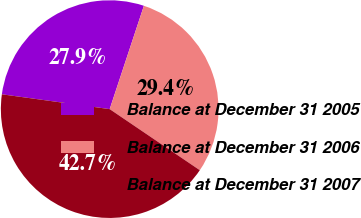<chart> <loc_0><loc_0><loc_500><loc_500><pie_chart><fcel>Balance at December 31 2005<fcel>Balance at December 31 2006<fcel>Balance at December 31 2007<nl><fcel>27.91%<fcel>29.39%<fcel>42.69%<nl></chart> 